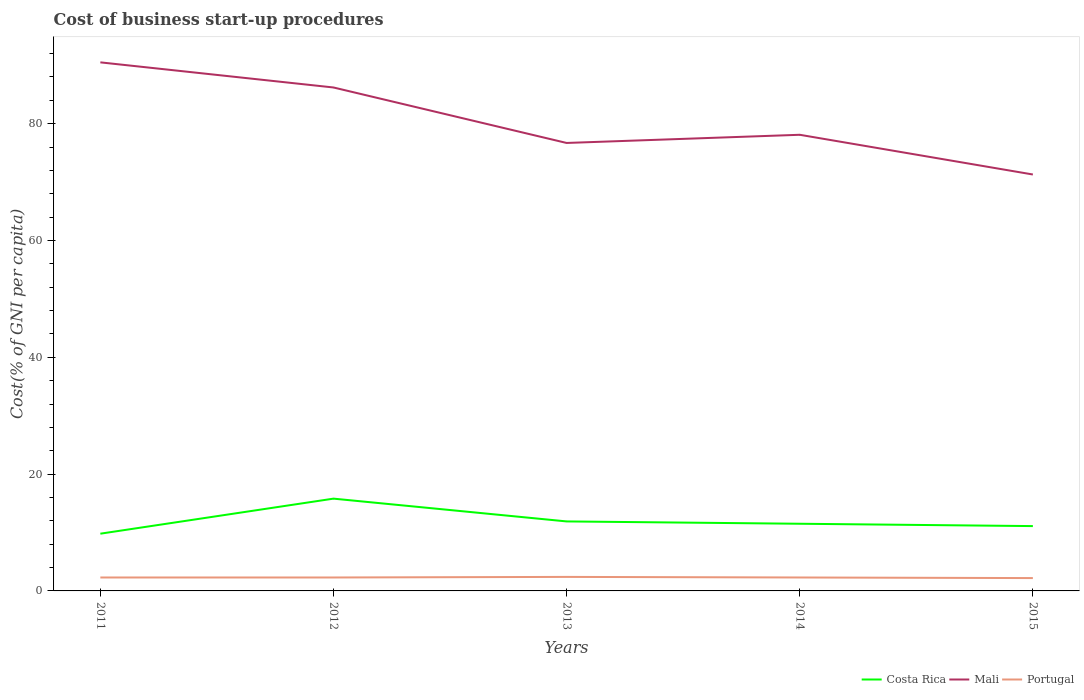In which year was the cost of business start-up procedures in Mali maximum?
Offer a terse response. 2015. What is the total cost of business start-up procedures in Portugal in the graph?
Your answer should be very brief. 0. What is the difference between the highest and the second highest cost of business start-up procedures in Portugal?
Give a very brief answer. 0.2. Is the cost of business start-up procedures in Costa Rica strictly greater than the cost of business start-up procedures in Mali over the years?
Ensure brevity in your answer.  Yes. How many years are there in the graph?
Keep it short and to the point. 5. Are the values on the major ticks of Y-axis written in scientific E-notation?
Keep it short and to the point. No. Does the graph contain any zero values?
Provide a short and direct response. No. What is the title of the graph?
Provide a succinct answer. Cost of business start-up procedures. Does "Bahrain" appear as one of the legend labels in the graph?
Keep it short and to the point. No. What is the label or title of the Y-axis?
Provide a short and direct response. Cost(% of GNI per capita). What is the Cost(% of GNI per capita) in Costa Rica in 2011?
Your response must be concise. 9.8. What is the Cost(% of GNI per capita) in Mali in 2011?
Offer a very short reply. 90.5. What is the Cost(% of GNI per capita) in Costa Rica in 2012?
Provide a short and direct response. 15.8. What is the Cost(% of GNI per capita) of Mali in 2012?
Ensure brevity in your answer.  86.2. What is the Cost(% of GNI per capita) of Portugal in 2012?
Provide a succinct answer. 2.3. What is the Cost(% of GNI per capita) in Costa Rica in 2013?
Give a very brief answer. 11.9. What is the Cost(% of GNI per capita) in Mali in 2013?
Offer a very short reply. 76.7. What is the Cost(% of GNI per capita) of Portugal in 2013?
Provide a succinct answer. 2.4. What is the Cost(% of GNI per capita) in Costa Rica in 2014?
Provide a short and direct response. 11.5. What is the Cost(% of GNI per capita) of Mali in 2014?
Keep it short and to the point. 78.1. What is the Cost(% of GNI per capita) in Costa Rica in 2015?
Your answer should be very brief. 11.1. What is the Cost(% of GNI per capita) of Mali in 2015?
Your answer should be very brief. 71.3. What is the Cost(% of GNI per capita) in Portugal in 2015?
Offer a very short reply. 2.2. Across all years, what is the maximum Cost(% of GNI per capita) of Costa Rica?
Your answer should be compact. 15.8. Across all years, what is the maximum Cost(% of GNI per capita) in Mali?
Ensure brevity in your answer.  90.5. Across all years, what is the maximum Cost(% of GNI per capita) in Portugal?
Provide a short and direct response. 2.4. Across all years, what is the minimum Cost(% of GNI per capita) in Mali?
Keep it short and to the point. 71.3. Across all years, what is the minimum Cost(% of GNI per capita) of Portugal?
Keep it short and to the point. 2.2. What is the total Cost(% of GNI per capita) of Costa Rica in the graph?
Make the answer very short. 60.1. What is the total Cost(% of GNI per capita) in Mali in the graph?
Your answer should be compact. 402.8. What is the total Cost(% of GNI per capita) in Portugal in the graph?
Give a very brief answer. 11.5. What is the difference between the Cost(% of GNI per capita) in Costa Rica in 2011 and that in 2012?
Keep it short and to the point. -6. What is the difference between the Cost(% of GNI per capita) of Portugal in 2011 and that in 2012?
Your answer should be very brief. 0. What is the difference between the Cost(% of GNI per capita) in Mali in 2011 and that in 2013?
Your response must be concise. 13.8. What is the difference between the Cost(% of GNI per capita) of Portugal in 2011 and that in 2013?
Keep it short and to the point. -0.1. What is the difference between the Cost(% of GNI per capita) of Costa Rica in 2011 and that in 2014?
Give a very brief answer. -1.7. What is the difference between the Cost(% of GNI per capita) in Mali in 2011 and that in 2014?
Your answer should be compact. 12.4. What is the difference between the Cost(% of GNI per capita) in Costa Rica in 2011 and that in 2015?
Give a very brief answer. -1.3. What is the difference between the Cost(% of GNI per capita) in Portugal in 2011 and that in 2015?
Give a very brief answer. 0.1. What is the difference between the Cost(% of GNI per capita) in Portugal in 2012 and that in 2013?
Your answer should be very brief. -0.1. What is the difference between the Cost(% of GNI per capita) of Mali in 2012 and that in 2014?
Your response must be concise. 8.1. What is the difference between the Cost(% of GNI per capita) of Portugal in 2012 and that in 2014?
Offer a terse response. 0. What is the difference between the Cost(% of GNI per capita) in Portugal in 2012 and that in 2015?
Give a very brief answer. 0.1. What is the difference between the Cost(% of GNI per capita) in Costa Rica in 2013 and that in 2014?
Provide a short and direct response. 0.4. What is the difference between the Cost(% of GNI per capita) of Mali in 2013 and that in 2014?
Provide a short and direct response. -1.4. What is the difference between the Cost(% of GNI per capita) in Costa Rica in 2013 and that in 2015?
Your answer should be compact. 0.8. What is the difference between the Cost(% of GNI per capita) of Costa Rica in 2014 and that in 2015?
Offer a terse response. 0.4. What is the difference between the Cost(% of GNI per capita) of Mali in 2014 and that in 2015?
Give a very brief answer. 6.8. What is the difference between the Cost(% of GNI per capita) of Portugal in 2014 and that in 2015?
Offer a terse response. 0.1. What is the difference between the Cost(% of GNI per capita) in Costa Rica in 2011 and the Cost(% of GNI per capita) in Mali in 2012?
Offer a very short reply. -76.4. What is the difference between the Cost(% of GNI per capita) in Costa Rica in 2011 and the Cost(% of GNI per capita) in Portugal in 2012?
Offer a very short reply. 7.5. What is the difference between the Cost(% of GNI per capita) in Mali in 2011 and the Cost(% of GNI per capita) in Portugal in 2012?
Make the answer very short. 88.2. What is the difference between the Cost(% of GNI per capita) of Costa Rica in 2011 and the Cost(% of GNI per capita) of Mali in 2013?
Keep it short and to the point. -66.9. What is the difference between the Cost(% of GNI per capita) of Mali in 2011 and the Cost(% of GNI per capita) of Portugal in 2013?
Ensure brevity in your answer.  88.1. What is the difference between the Cost(% of GNI per capita) of Costa Rica in 2011 and the Cost(% of GNI per capita) of Mali in 2014?
Offer a terse response. -68.3. What is the difference between the Cost(% of GNI per capita) in Mali in 2011 and the Cost(% of GNI per capita) in Portugal in 2014?
Your response must be concise. 88.2. What is the difference between the Cost(% of GNI per capita) of Costa Rica in 2011 and the Cost(% of GNI per capita) of Mali in 2015?
Give a very brief answer. -61.5. What is the difference between the Cost(% of GNI per capita) of Costa Rica in 2011 and the Cost(% of GNI per capita) of Portugal in 2015?
Keep it short and to the point. 7.6. What is the difference between the Cost(% of GNI per capita) of Mali in 2011 and the Cost(% of GNI per capita) of Portugal in 2015?
Make the answer very short. 88.3. What is the difference between the Cost(% of GNI per capita) of Costa Rica in 2012 and the Cost(% of GNI per capita) of Mali in 2013?
Keep it short and to the point. -60.9. What is the difference between the Cost(% of GNI per capita) of Costa Rica in 2012 and the Cost(% of GNI per capita) of Portugal in 2013?
Ensure brevity in your answer.  13.4. What is the difference between the Cost(% of GNI per capita) in Mali in 2012 and the Cost(% of GNI per capita) in Portugal in 2013?
Provide a short and direct response. 83.8. What is the difference between the Cost(% of GNI per capita) of Costa Rica in 2012 and the Cost(% of GNI per capita) of Mali in 2014?
Provide a short and direct response. -62.3. What is the difference between the Cost(% of GNI per capita) in Costa Rica in 2012 and the Cost(% of GNI per capita) in Portugal in 2014?
Your response must be concise. 13.5. What is the difference between the Cost(% of GNI per capita) in Mali in 2012 and the Cost(% of GNI per capita) in Portugal in 2014?
Your answer should be very brief. 83.9. What is the difference between the Cost(% of GNI per capita) of Costa Rica in 2012 and the Cost(% of GNI per capita) of Mali in 2015?
Provide a succinct answer. -55.5. What is the difference between the Cost(% of GNI per capita) of Costa Rica in 2013 and the Cost(% of GNI per capita) of Mali in 2014?
Provide a short and direct response. -66.2. What is the difference between the Cost(% of GNI per capita) of Mali in 2013 and the Cost(% of GNI per capita) of Portugal in 2014?
Ensure brevity in your answer.  74.4. What is the difference between the Cost(% of GNI per capita) in Costa Rica in 2013 and the Cost(% of GNI per capita) in Mali in 2015?
Offer a terse response. -59.4. What is the difference between the Cost(% of GNI per capita) in Costa Rica in 2013 and the Cost(% of GNI per capita) in Portugal in 2015?
Offer a terse response. 9.7. What is the difference between the Cost(% of GNI per capita) in Mali in 2013 and the Cost(% of GNI per capita) in Portugal in 2015?
Your response must be concise. 74.5. What is the difference between the Cost(% of GNI per capita) in Costa Rica in 2014 and the Cost(% of GNI per capita) in Mali in 2015?
Your answer should be very brief. -59.8. What is the difference between the Cost(% of GNI per capita) of Costa Rica in 2014 and the Cost(% of GNI per capita) of Portugal in 2015?
Keep it short and to the point. 9.3. What is the difference between the Cost(% of GNI per capita) in Mali in 2014 and the Cost(% of GNI per capita) in Portugal in 2015?
Your answer should be compact. 75.9. What is the average Cost(% of GNI per capita) in Costa Rica per year?
Provide a succinct answer. 12.02. What is the average Cost(% of GNI per capita) of Mali per year?
Offer a very short reply. 80.56. In the year 2011, what is the difference between the Cost(% of GNI per capita) of Costa Rica and Cost(% of GNI per capita) of Mali?
Make the answer very short. -80.7. In the year 2011, what is the difference between the Cost(% of GNI per capita) in Costa Rica and Cost(% of GNI per capita) in Portugal?
Make the answer very short. 7.5. In the year 2011, what is the difference between the Cost(% of GNI per capita) of Mali and Cost(% of GNI per capita) of Portugal?
Provide a succinct answer. 88.2. In the year 2012, what is the difference between the Cost(% of GNI per capita) of Costa Rica and Cost(% of GNI per capita) of Mali?
Keep it short and to the point. -70.4. In the year 2012, what is the difference between the Cost(% of GNI per capita) of Mali and Cost(% of GNI per capita) of Portugal?
Make the answer very short. 83.9. In the year 2013, what is the difference between the Cost(% of GNI per capita) in Costa Rica and Cost(% of GNI per capita) in Mali?
Provide a succinct answer. -64.8. In the year 2013, what is the difference between the Cost(% of GNI per capita) of Mali and Cost(% of GNI per capita) of Portugal?
Provide a short and direct response. 74.3. In the year 2014, what is the difference between the Cost(% of GNI per capita) of Costa Rica and Cost(% of GNI per capita) of Mali?
Make the answer very short. -66.6. In the year 2014, what is the difference between the Cost(% of GNI per capita) in Mali and Cost(% of GNI per capita) in Portugal?
Give a very brief answer. 75.8. In the year 2015, what is the difference between the Cost(% of GNI per capita) in Costa Rica and Cost(% of GNI per capita) in Mali?
Offer a terse response. -60.2. In the year 2015, what is the difference between the Cost(% of GNI per capita) of Costa Rica and Cost(% of GNI per capita) of Portugal?
Your answer should be compact. 8.9. In the year 2015, what is the difference between the Cost(% of GNI per capita) of Mali and Cost(% of GNI per capita) of Portugal?
Provide a succinct answer. 69.1. What is the ratio of the Cost(% of GNI per capita) in Costa Rica in 2011 to that in 2012?
Your answer should be compact. 0.62. What is the ratio of the Cost(% of GNI per capita) in Mali in 2011 to that in 2012?
Keep it short and to the point. 1.05. What is the ratio of the Cost(% of GNI per capita) in Costa Rica in 2011 to that in 2013?
Provide a short and direct response. 0.82. What is the ratio of the Cost(% of GNI per capita) in Mali in 2011 to that in 2013?
Your answer should be very brief. 1.18. What is the ratio of the Cost(% of GNI per capita) in Portugal in 2011 to that in 2013?
Your answer should be very brief. 0.96. What is the ratio of the Cost(% of GNI per capita) of Costa Rica in 2011 to that in 2014?
Your answer should be compact. 0.85. What is the ratio of the Cost(% of GNI per capita) of Mali in 2011 to that in 2014?
Provide a short and direct response. 1.16. What is the ratio of the Cost(% of GNI per capita) in Portugal in 2011 to that in 2014?
Provide a succinct answer. 1. What is the ratio of the Cost(% of GNI per capita) in Costa Rica in 2011 to that in 2015?
Your response must be concise. 0.88. What is the ratio of the Cost(% of GNI per capita) of Mali in 2011 to that in 2015?
Keep it short and to the point. 1.27. What is the ratio of the Cost(% of GNI per capita) in Portugal in 2011 to that in 2015?
Your answer should be compact. 1.05. What is the ratio of the Cost(% of GNI per capita) of Costa Rica in 2012 to that in 2013?
Offer a terse response. 1.33. What is the ratio of the Cost(% of GNI per capita) of Mali in 2012 to that in 2013?
Provide a succinct answer. 1.12. What is the ratio of the Cost(% of GNI per capita) in Costa Rica in 2012 to that in 2014?
Your response must be concise. 1.37. What is the ratio of the Cost(% of GNI per capita) of Mali in 2012 to that in 2014?
Offer a very short reply. 1.1. What is the ratio of the Cost(% of GNI per capita) in Costa Rica in 2012 to that in 2015?
Your answer should be very brief. 1.42. What is the ratio of the Cost(% of GNI per capita) of Mali in 2012 to that in 2015?
Offer a very short reply. 1.21. What is the ratio of the Cost(% of GNI per capita) in Portugal in 2012 to that in 2015?
Provide a succinct answer. 1.05. What is the ratio of the Cost(% of GNI per capita) of Costa Rica in 2013 to that in 2014?
Your answer should be very brief. 1.03. What is the ratio of the Cost(% of GNI per capita) in Mali in 2013 to that in 2014?
Offer a terse response. 0.98. What is the ratio of the Cost(% of GNI per capita) in Portugal in 2013 to that in 2014?
Your answer should be very brief. 1.04. What is the ratio of the Cost(% of GNI per capita) in Costa Rica in 2013 to that in 2015?
Offer a very short reply. 1.07. What is the ratio of the Cost(% of GNI per capita) in Mali in 2013 to that in 2015?
Provide a short and direct response. 1.08. What is the ratio of the Cost(% of GNI per capita) in Costa Rica in 2014 to that in 2015?
Keep it short and to the point. 1.04. What is the ratio of the Cost(% of GNI per capita) in Mali in 2014 to that in 2015?
Make the answer very short. 1.1. What is the ratio of the Cost(% of GNI per capita) of Portugal in 2014 to that in 2015?
Offer a very short reply. 1.05. What is the difference between the highest and the second highest Cost(% of GNI per capita) of Costa Rica?
Keep it short and to the point. 3.9. What is the difference between the highest and the second highest Cost(% of GNI per capita) of Portugal?
Your answer should be compact. 0.1. What is the difference between the highest and the lowest Cost(% of GNI per capita) of Costa Rica?
Your response must be concise. 6. 